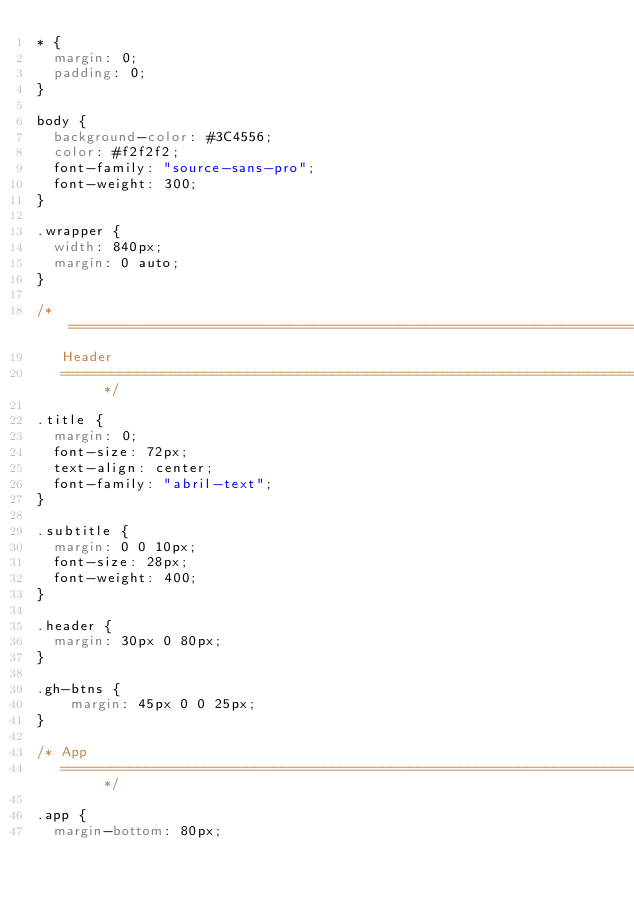<code> <loc_0><loc_0><loc_500><loc_500><_CSS_>* {
	margin: 0;
	padding: 0;
}

body {
	background-color: #3C4556;
	color: #f2f2f2;
	font-family: "source-sans-pro";
	font-weight: 300;
}

.wrapper {
	width: 840px;
	margin: 0 auto;
}

/* ==========================================================================
   Header
   ========================================================================== */

.title {
	margin: 0;
	font-size: 72px;
	text-align: center;
	font-family: "abril-text";
}

.subtitle {
	margin: 0 0 10px;
	font-size: 28px;
	font-weight: 400;
}

.header {
	margin: 30px 0 80px;
}

.gh-btns {
    margin: 45px 0 0 25px;
}

/* App
   ========================================================================== */

.app {
	margin-bottom: 80px;</code> 